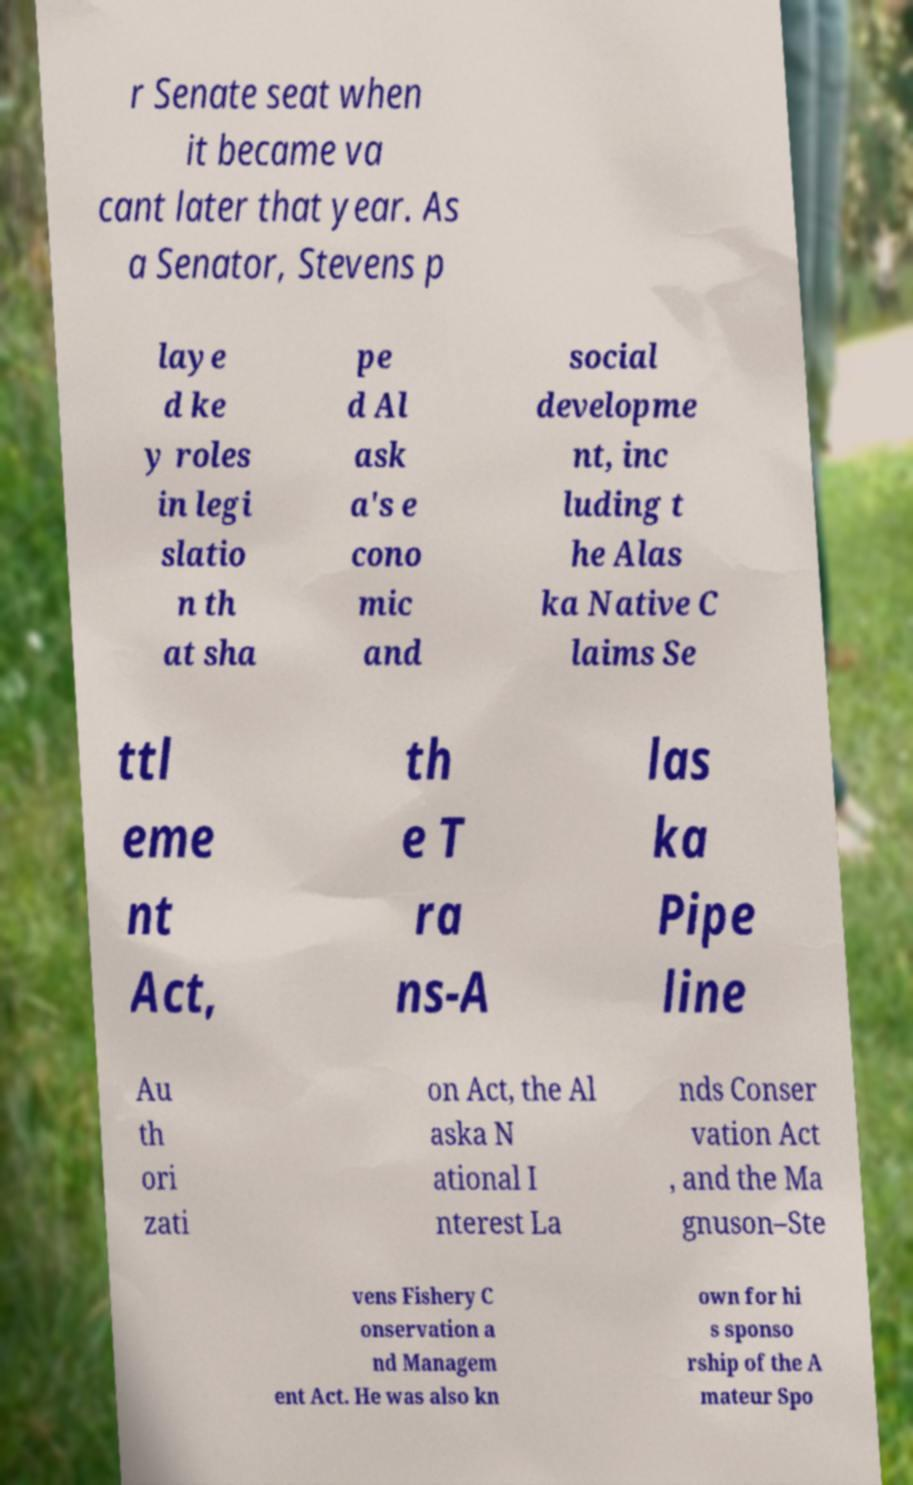For documentation purposes, I need the text within this image transcribed. Could you provide that? r Senate seat when it became va cant later that year. As a Senator, Stevens p laye d ke y roles in legi slatio n th at sha pe d Al ask a's e cono mic and social developme nt, inc luding t he Alas ka Native C laims Se ttl eme nt Act, th e T ra ns-A las ka Pipe line Au th ori zati on Act, the Al aska N ational I nterest La nds Conser vation Act , and the Ma gnuson–Ste vens Fishery C onservation a nd Managem ent Act. He was also kn own for hi s sponso rship of the A mateur Spo 